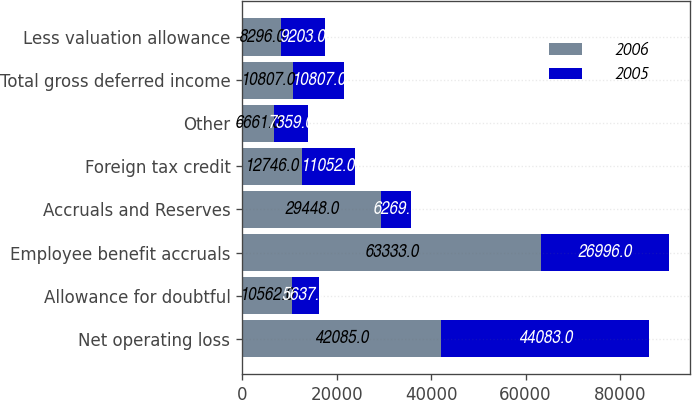Convert chart. <chart><loc_0><loc_0><loc_500><loc_500><stacked_bar_chart><ecel><fcel>Net operating loss<fcel>Allowance for doubtful<fcel>Employee benefit accruals<fcel>Accruals and Reserves<fcel>Foreign tax credit<fcel>Other<fcel>Total gross deferred income<fcel>Less valuation allowance<nl><fcel>2006<fcel>42085<fcel>10562<fcel>63333<fcel>29448<fcel>12746<fcel>6661<fcel>10807<fcel>8296<nl><fcel>2005<fcel>44083<fcel>5637<fcel>26996<fcel>6269<fcel>11052<fcel>7359<fcel>10807<fcel>9203<nl></chart> 